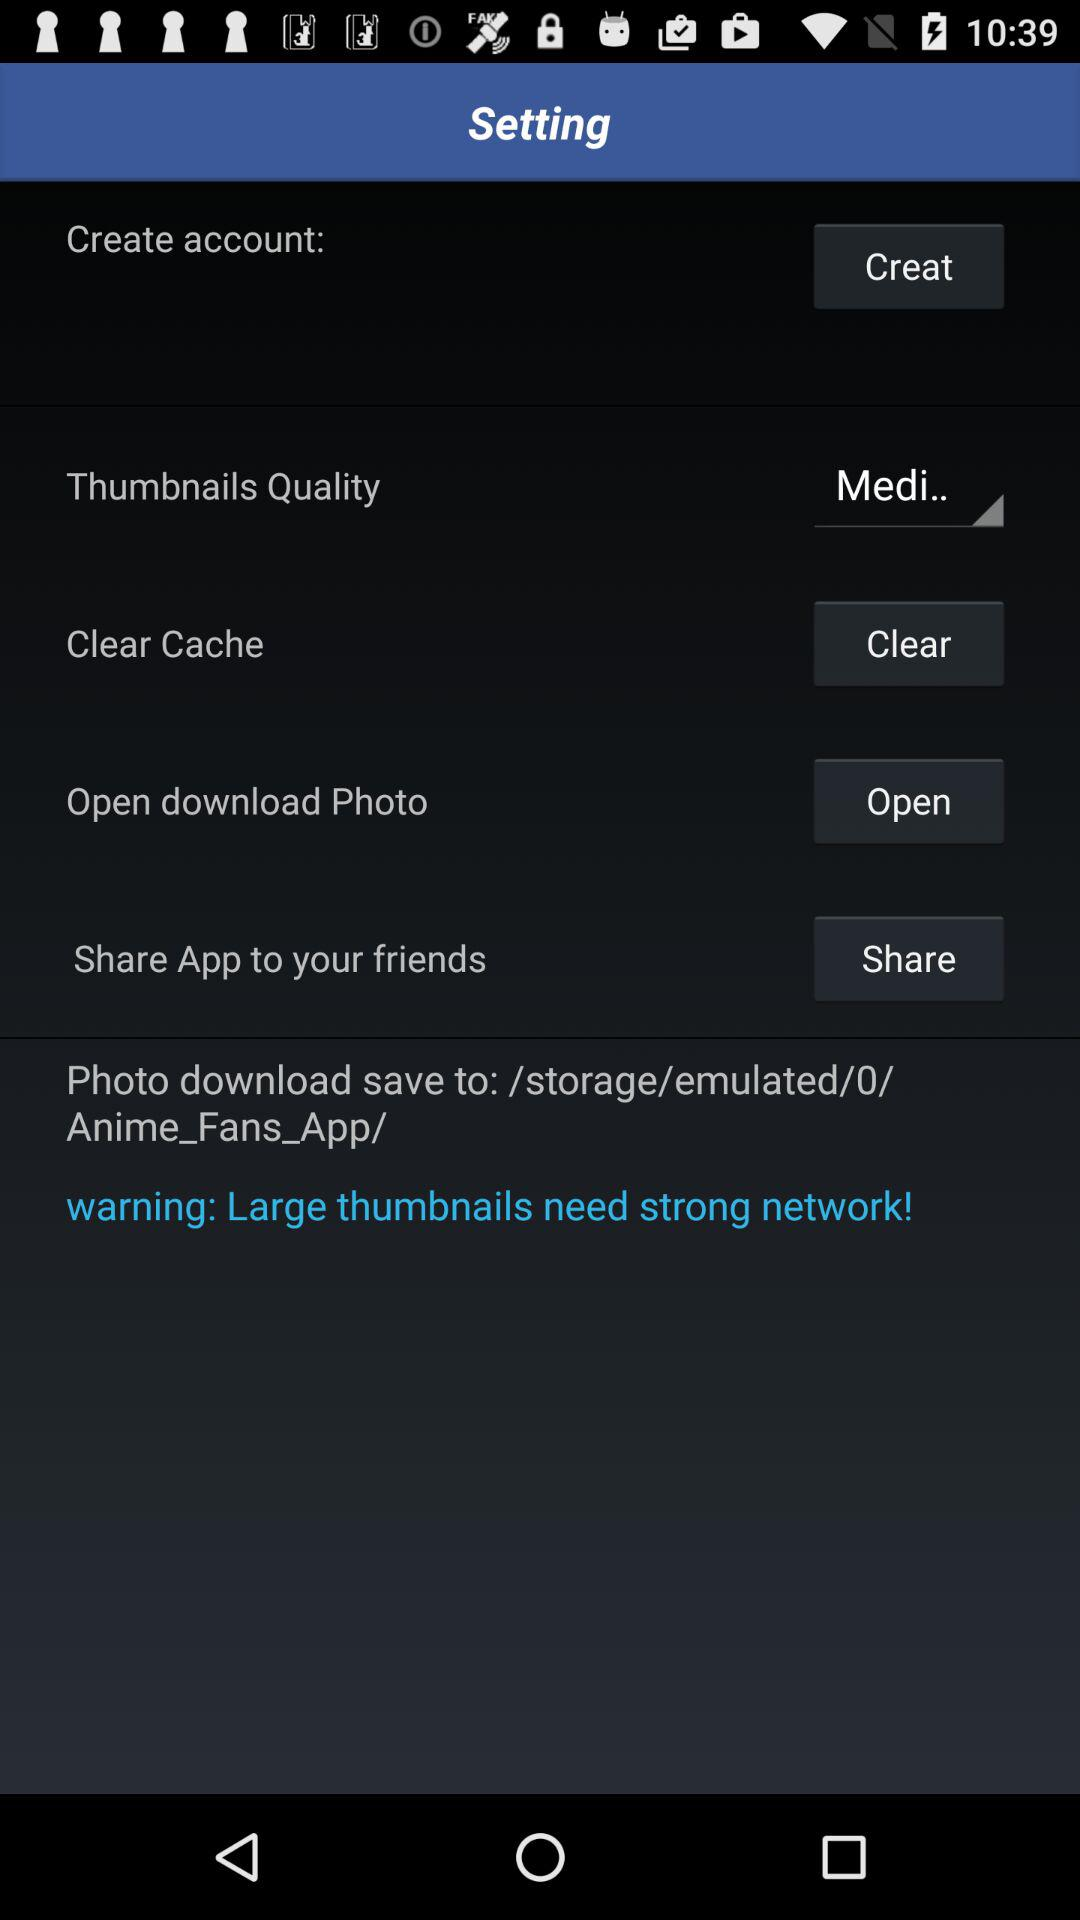Which options are available for the thumbnails quality?
When the provided information is insufficient, respond with <no answer>. <no answer> 